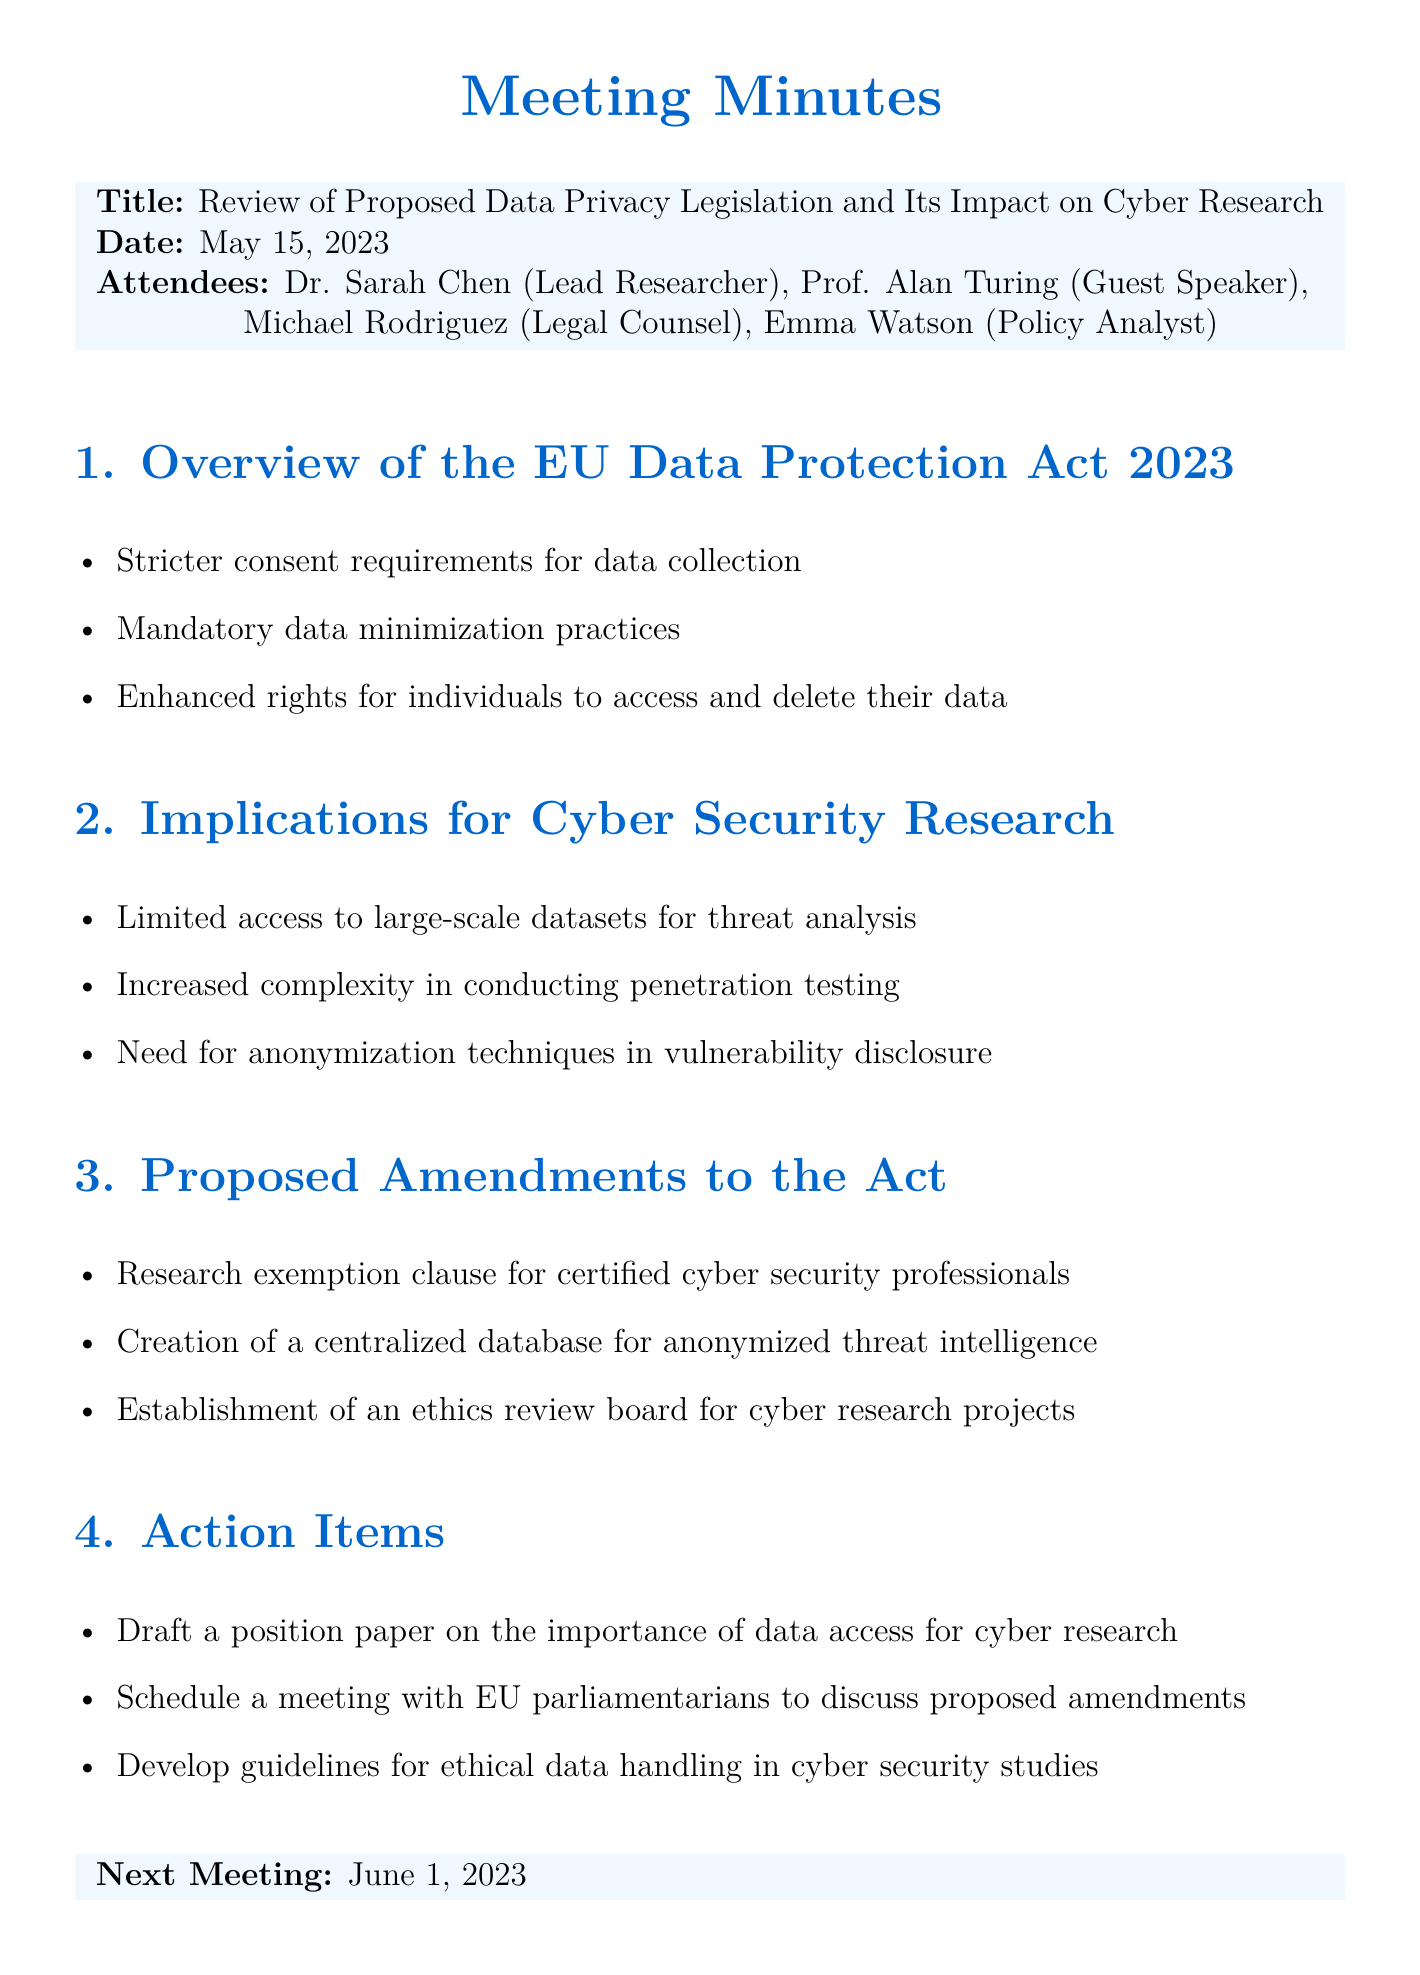What is the meeting title? The meeting title is stated at the beginning of the document.
Answer: Review of Proposed Data Privacy Legislation and Its Impact on Cyber Research Who was the guest speaker? The guest speaker is listed among the attendees.
Answer: Prof. Alan Turing What date was the meeting held? The date is explicitly mentioned in the document.
Answer: May 15, 2023 What are the enhanced rights for individuals according to the EU Data Protection Act 2023? This information is detailed in the first agenda item.
Answer: To access and delete their data What is the proposed research exemption clause meant for? This information appears in the section discussing proposed amendments to the Act.
Answer: Certified cyber security professionals What is one action item listed in the document? Action items are provided in the last section of the document.
Answer: Draft a position paper on the importance of data access for cyber research What is the next meeting date? This information is provided at the end of the document.
Answer: June 1, 2023 What does the second agenda item discuss? The second agenda item focuses on implications relevant to a specific field of study.
Answer: Implications for Cyber Security Research What is the significance of the centralized database mentioned in the proposed amendments? The significance relates to the handling of threat intelligence in the context of cyber research.
Answer: For anonymized threat intelligence 